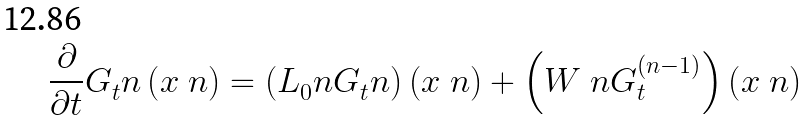Convert formula to latex. <formula><loc_0><loc_0><loc_500><loc_500>\frac { \partial } { \partial t } G _ { t } ^ { \ } n \left ( x ^ { \ } n \right ) = \left ( L _ { 0 } ^ { \ } n G _ { t } ^ { \ } n \right ) \left ( x ^ { \ } n \right ) + \left ( W ^ { \ } n G _ { t } ^ { ( n - 1 ) } \right ) \left ( x ^ { \ } n \right )</formula> 